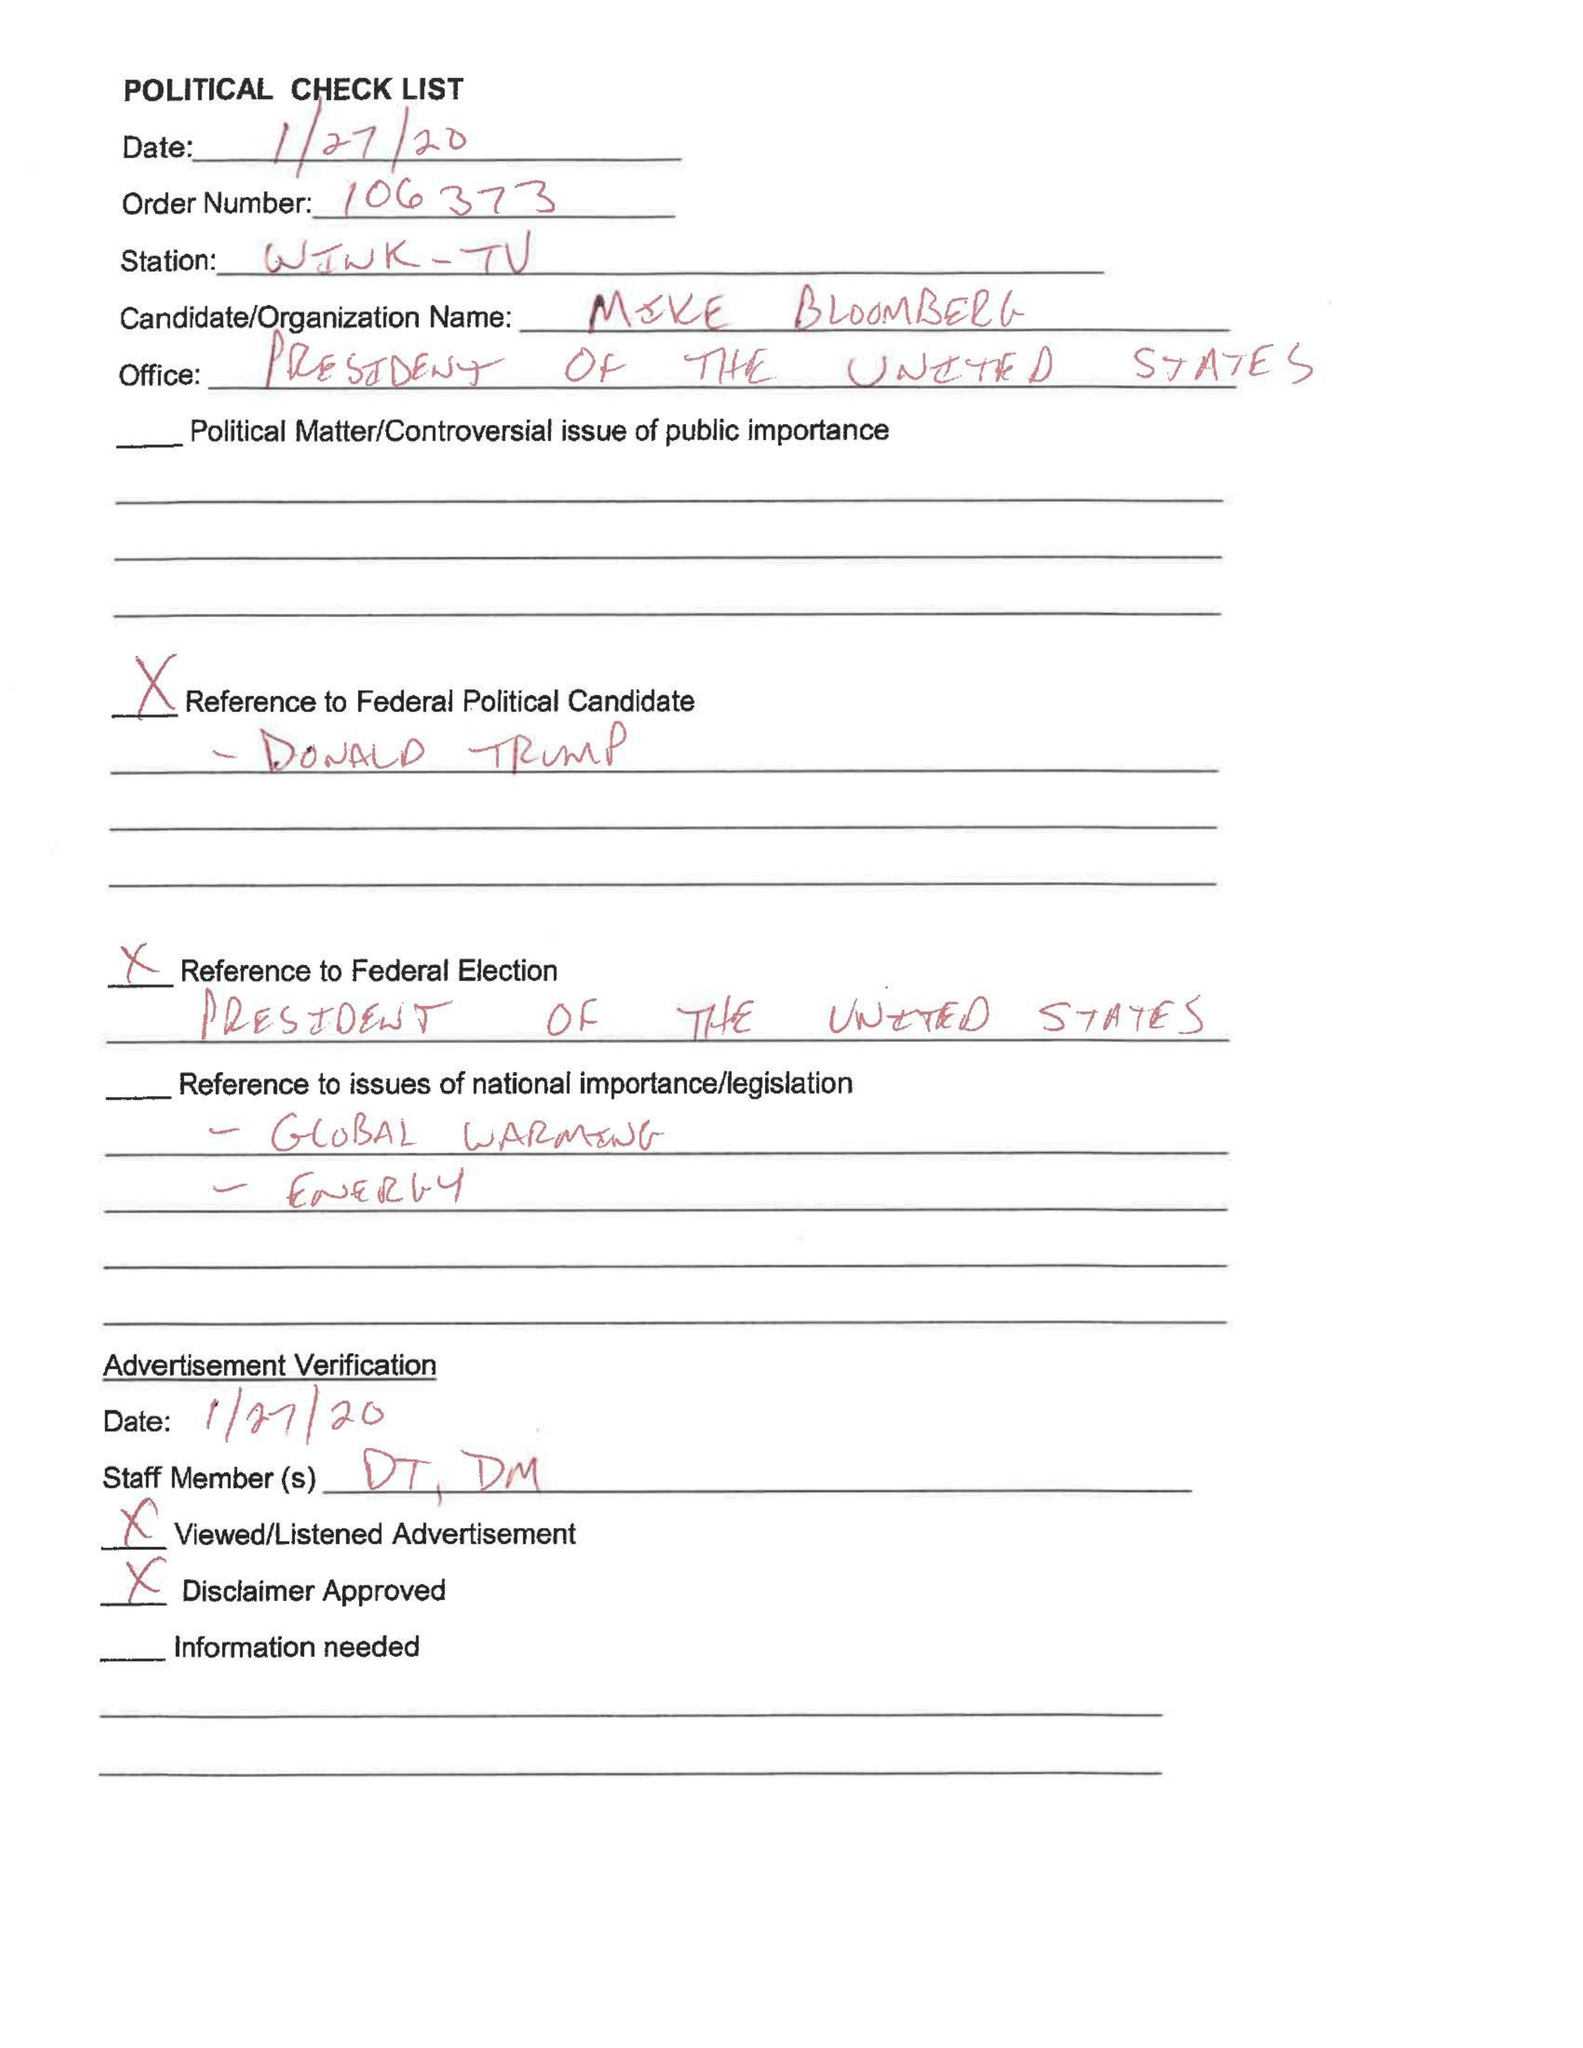What is the value for the flight_to?
Answer the question using a single word or phrase. None 